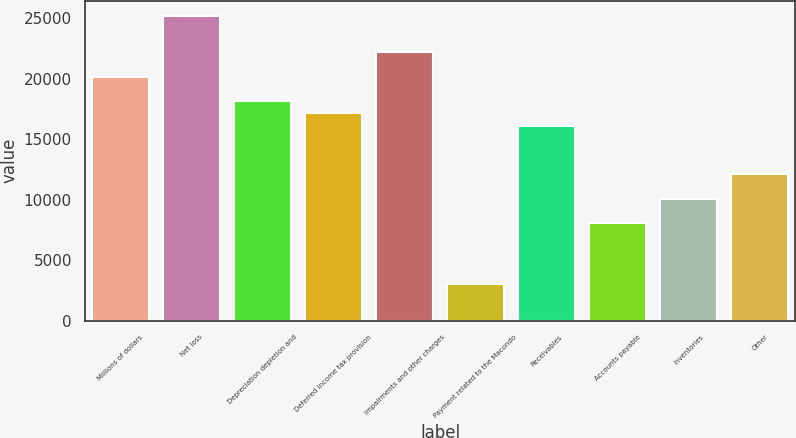<chart> <loc_0><loc_0><loc_500><loc_500><bar_chart><fcel>Millions of dollars<fcel>Net loss<fcel>Depreciation depletion and<fcel>Deferred income tax provision<fcel>Impairments and other charges<fcel>Payment related to the Macondo<fcel>Receivables<fcel>Accounts payable<fcel>Inventories<fcel>Other<nl><fcel>20145<fcel>25179<fcel>18131.4<fcel>17124.6<fcel>22158.6<fcel>3029.4<fcel>16117.8<fcel>8063.4<fcel>10077<fcel>12090.6<nl></chart> 